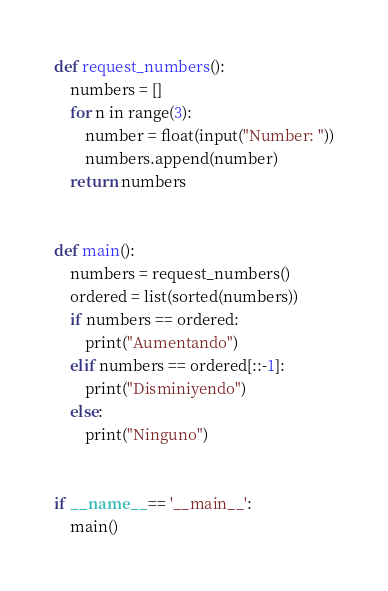Convert code to text. <code><loc_0><loc_0><loc_500><loc_500><_Python_>def request_numbers():
    numbers = []
    for n in range(3):
        number = float(input("Number: "))
        numbers.append(number)
    return numbers


def main():
    numbers = request_numbers()
    ordered = list(sorted(numbers))
    if numbers == ordered:
        print("Aumentando")
    elif numbers == ordered[::-1]:
        print("Disminiyendo")
    else:
        print("Ninguno")


if __name__ == '__main__':
    main()
</code> 